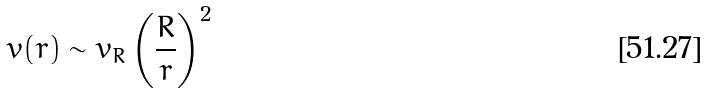<formula> <loc_0><loc_0><loc_500><loc_500>v ( r ) \sim v _ { R } \left ( \frac { R } { r } \right ) ^ { 2 }</formula> 